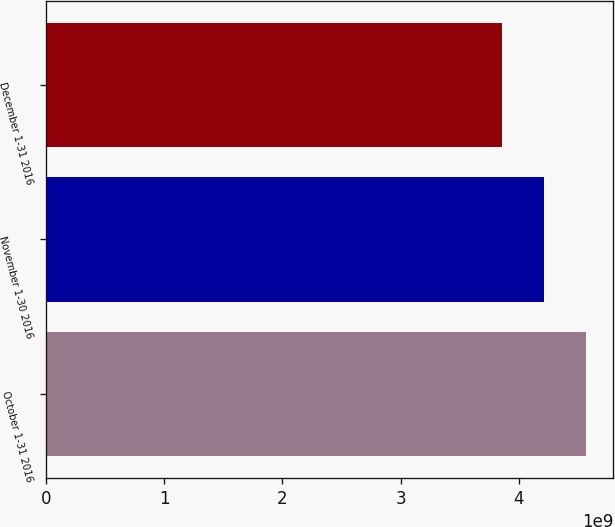<chart> <loc_0><loc_0><loc_500><loc_500><bar_chart><fcel>October 1-31 2016<fcel>November 1-30 2016<fcel>December 1-31 2016<nl><fcel>4.57114e+09<fcel>4.21351e+09<fcel>3.85857e+09<nl></chart> 